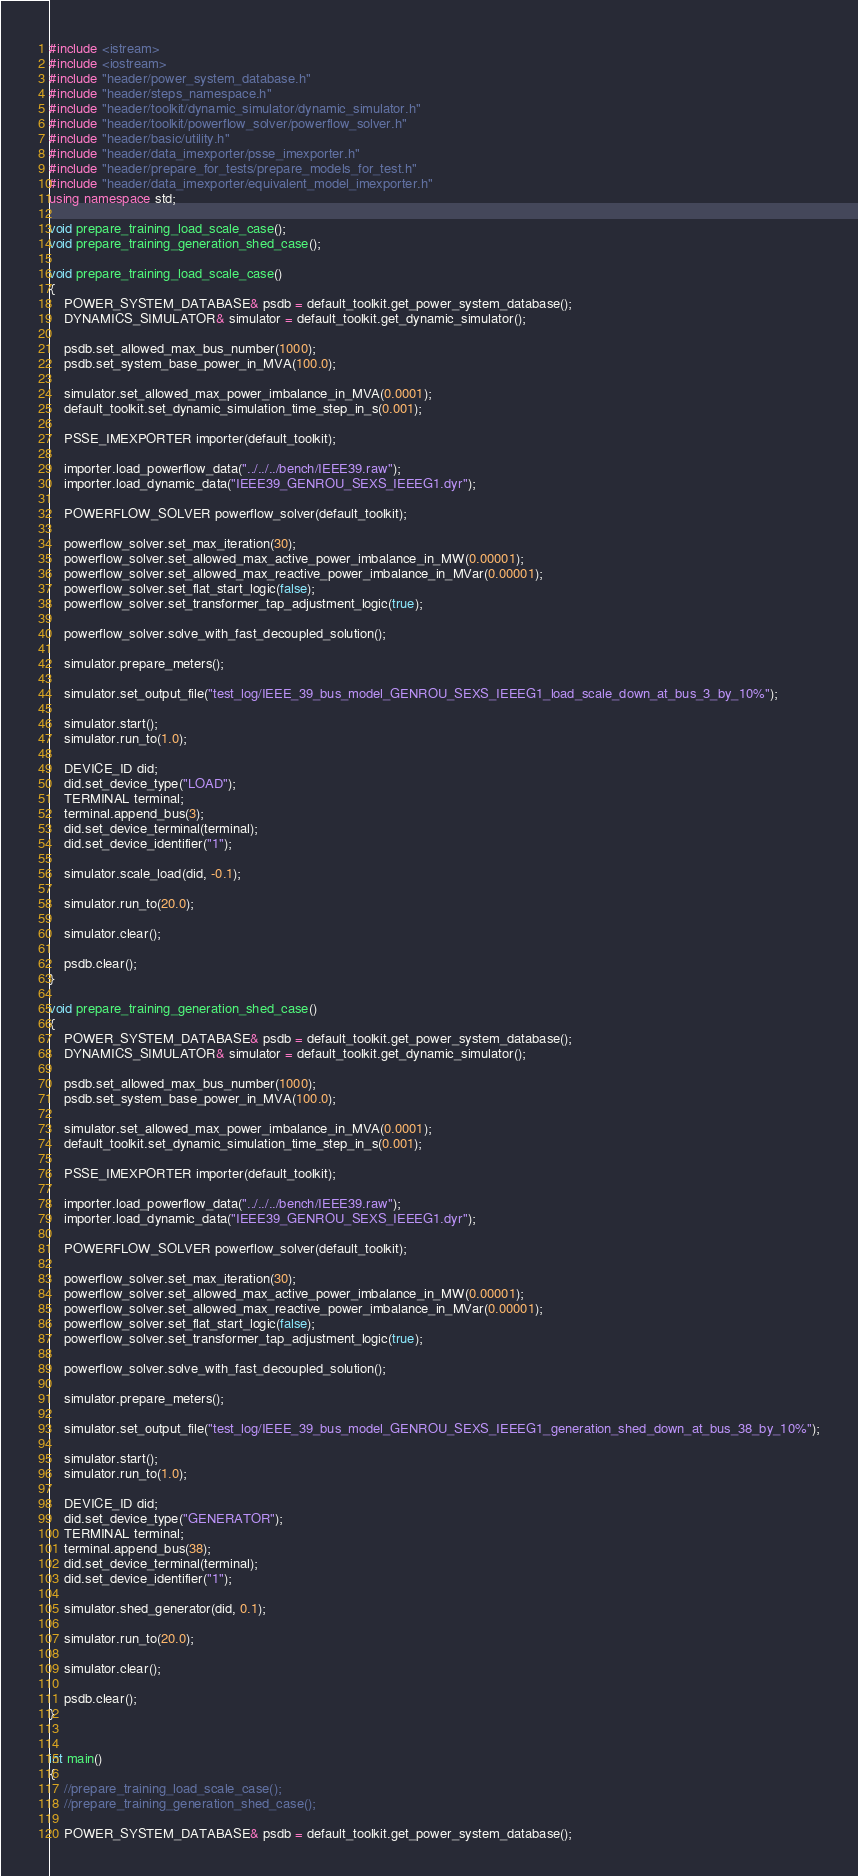Convert code to text. <code><loc_0><loc_0><loc_500><loc_500><_C++_>#include <istream>
#include <iostream>
#include "header/power_system_database.h"
#include "header/steps_namespace.h"
#include "header/toolkit/dynamic_simulator/dynamic_simulator.h"
#include "header/toolkit/powerflow_solver/powerflow_solver.h"
#include "header/basic/utility.h"
#include "header/data_imexporter/psse_imexporter.h"
#include "header/prepare_for_tests/prepare_models_for_test.h"
#include "header/data_imexporter/equivalent_model_imexporter.h"
using namespace std;

void prepare_training_load_scale_case();
void prepare_training_generation_shed_case();

void prepare_training_load_scale_case()
{
    POWER_SYSTEM_DATABASE& psdb = default_toolkit.get_power_system_database();
    DYNAMICS_SIMULATOR& simulator = default_toolkit.get_dynamic_simulator();

    psdb.set_allowed_max_bus_number(1000);
    psdb.set_system_base_power_in_MVA(100.0);

    simulator.set_allowed_max_power_imbalance_in_MVA(0.0001);
    default_toolkit.set_dynamic_simulation_time_step_in_s(0.001);

    PSSE_IMEXPORTER importer(default_toolkit);

    importer.load_powerflow_data("../../../bench/IEEE39.raw");
    importer.load_dynamic_data("IEEE39_GENROU_SEXS_IEEEG1.dyr");

    POWERFLOW_SOLVER powerflow_solver(default_toolkit);

    powerflow_solver.set_max_iteration(30);
    powerflow_solver.set_allowed_max_active_power_imbalance_in_MW(0.00001);
    powerflow_solver.set_allowed_max_reactive_power_imbalance_in_MVar(0.00001);
    powerflow_solver.set_flat_start_logic(false);
    powerflow_solver.set_transformer_tap_adjustment_logic(true);

    powerflow_solver.solve_with_fast_decoupled_solution();

    simulator.prepare_meters();

    simulator.set_output_file("test_log/IEEE_39_bus_model_GENROU_SEXS_IEEEG1_load_scale_down_at_bus_3_by_10%");

    simulator.start();
    simulator.run_to(1.0);

    DEVICE_ID did;
    did.set_device_type("LOAD");
    TERMINAL terminal;
    terminal.append_bus(3);
    did.set_device_terminal(terminal);
    did.set_device_identifier("1");

    simulator.scale_load(did, -0.1);

    simulator.run_to(20.0);

    simulator.clear();

    psdb.clear();
}

void prepare_training_generation_shed_case()
{
    POWER_SYSTEM_DATABASE& psdb = default_toolkit.get_power_system_database();
    DYNAMICS_SIMULATOR& simulator = default_toolkit.get_dynamic_simulator();

    psdb.set_allowed_max_bus_number(1000);
    psdb.set_system_base_power_in_MVA(100.0);

    simulator.set_allowed_max_power_imbalance_in_MVA(0.0001);
    default_toolkit.set_dynamic_simulation_time_step_in_s(0.001);

    PSSE_IMEXPORTER importer(default_toolkit);

    importer.load_powerflow_data("../../../bench/IEEE39.raw");
    importer.load_dynamic_data("IEEE39_GENROU_SEXS_IEEEG1.dyr");

    POWERFLOW_SOLVER powerflow_solver(default_toolkit);

    powerflow_solver.set_max_iteration(30);
    powerflow_solver.set_allowed_max_active_power_imbalance_in_MW(0.00001);
    powerflow_solver.set_allowed_max_reactive_power_imbalance_in_MVar(0.00001);
    powerflow_solver.set_flat_start_logic(false);
    powerflow_solver.set_transformer_tap_adjustment_logic(true);

    powerflow_solver.solve_with_fast_decoupled_solution();

    simulator.prepare_meters();

    simulator.set_output_file("test_log/IEEE_39_bus_model_GENROU_SEXS_IEEEG1_generation_shed_down_at_bus_38_by_10%");

    simulator.start();
    simulator.run_to(1.0);

    DEVICE_ID did;
    did.set_device_type("GENERATOR");
    TERMINAL terminal;
    terminal.append_bus(38);
    did.set_device_terminal(terminal);
    did.set_device_identifier("1");

    simulator.shed_generator(did, 0.1);

    simulator.run_to(20.0);

    simulator.clear();

    psdb.clear();
}


int main()
{
    //prepare_training_load_scale_case();
    //prepare_training_generation_shed_case();

    POWER_SYSTEM_DATABASE& psdb = default_toolkit.get_power_system_database();</code> 